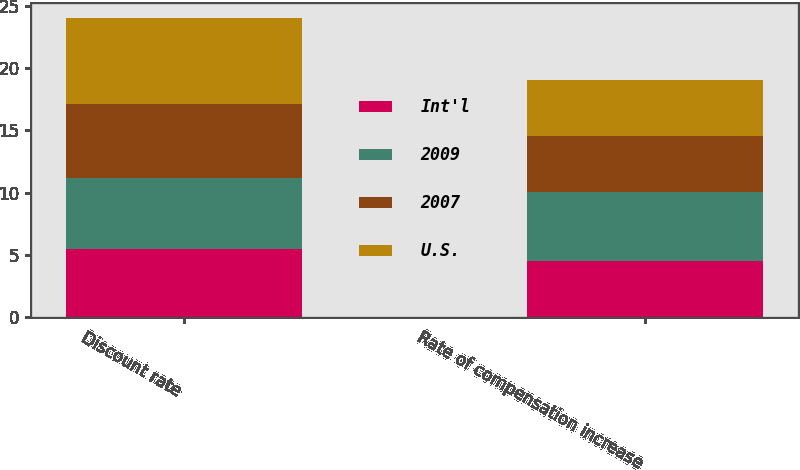Convert chart to OTSL. <chart><loc_0><loc_0><loc_500><loc_500><stacked_bar_chart><ecel><fcel>Discount rate<fcel>Rate of compensation increase<nl><fcel>Int'l<fcel>5.5<fcel>4.5<nl><fcel>2009<fcel>5.7<fcel>5.55<nl><fcel>2007<fcel>5.95<fcel>4.5<nl><fcel>U.S.<fcel>6.85<fcel>4.5<nl></chart> 